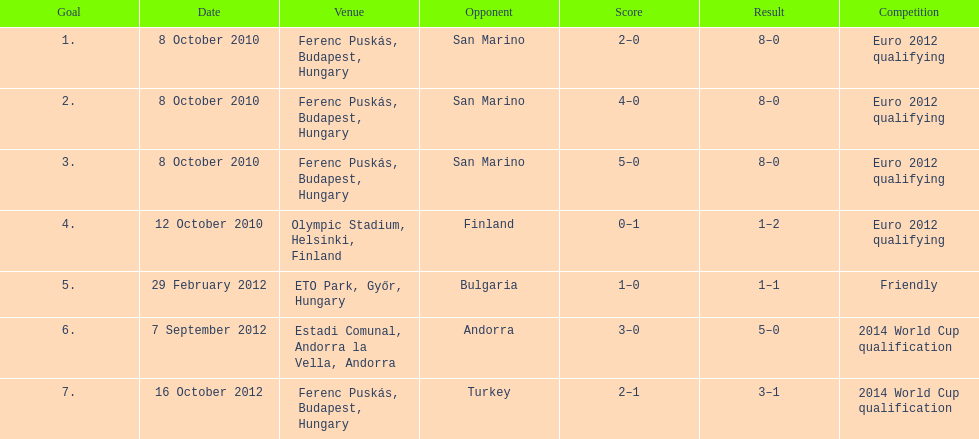What was ádám szalai's goal count in the 2010 match against san marino? 3. 